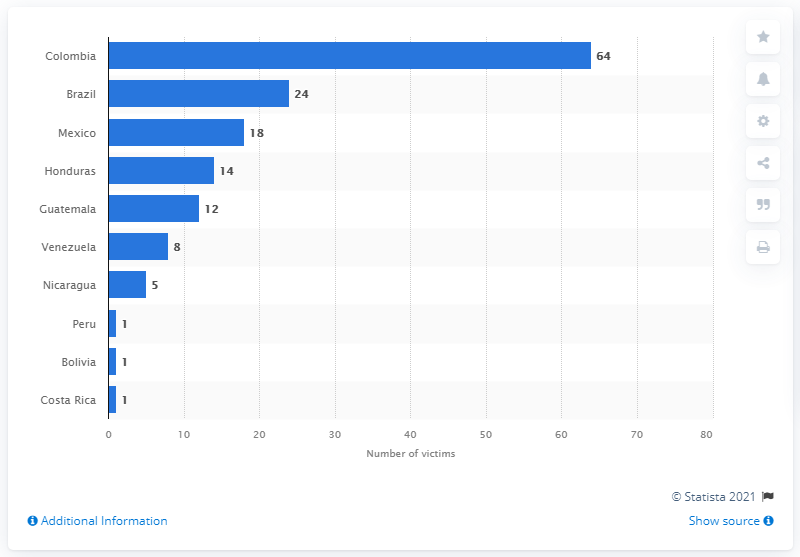Highlight a few significant elements in this photo. According to statistics, 24 environmentalists were killed in Brazil in 2019. This reflects a concerning trend of violence against those who work to protect the environment. In 2019, a staggering 64 environmental activists were murdered in Colombia, a testament to the dangerous and hostile environment in which these brave individuals work to protect the planet. According to data released in 2019, Colombia was the deadliest Latin American country for land activists and environmental defenders. 